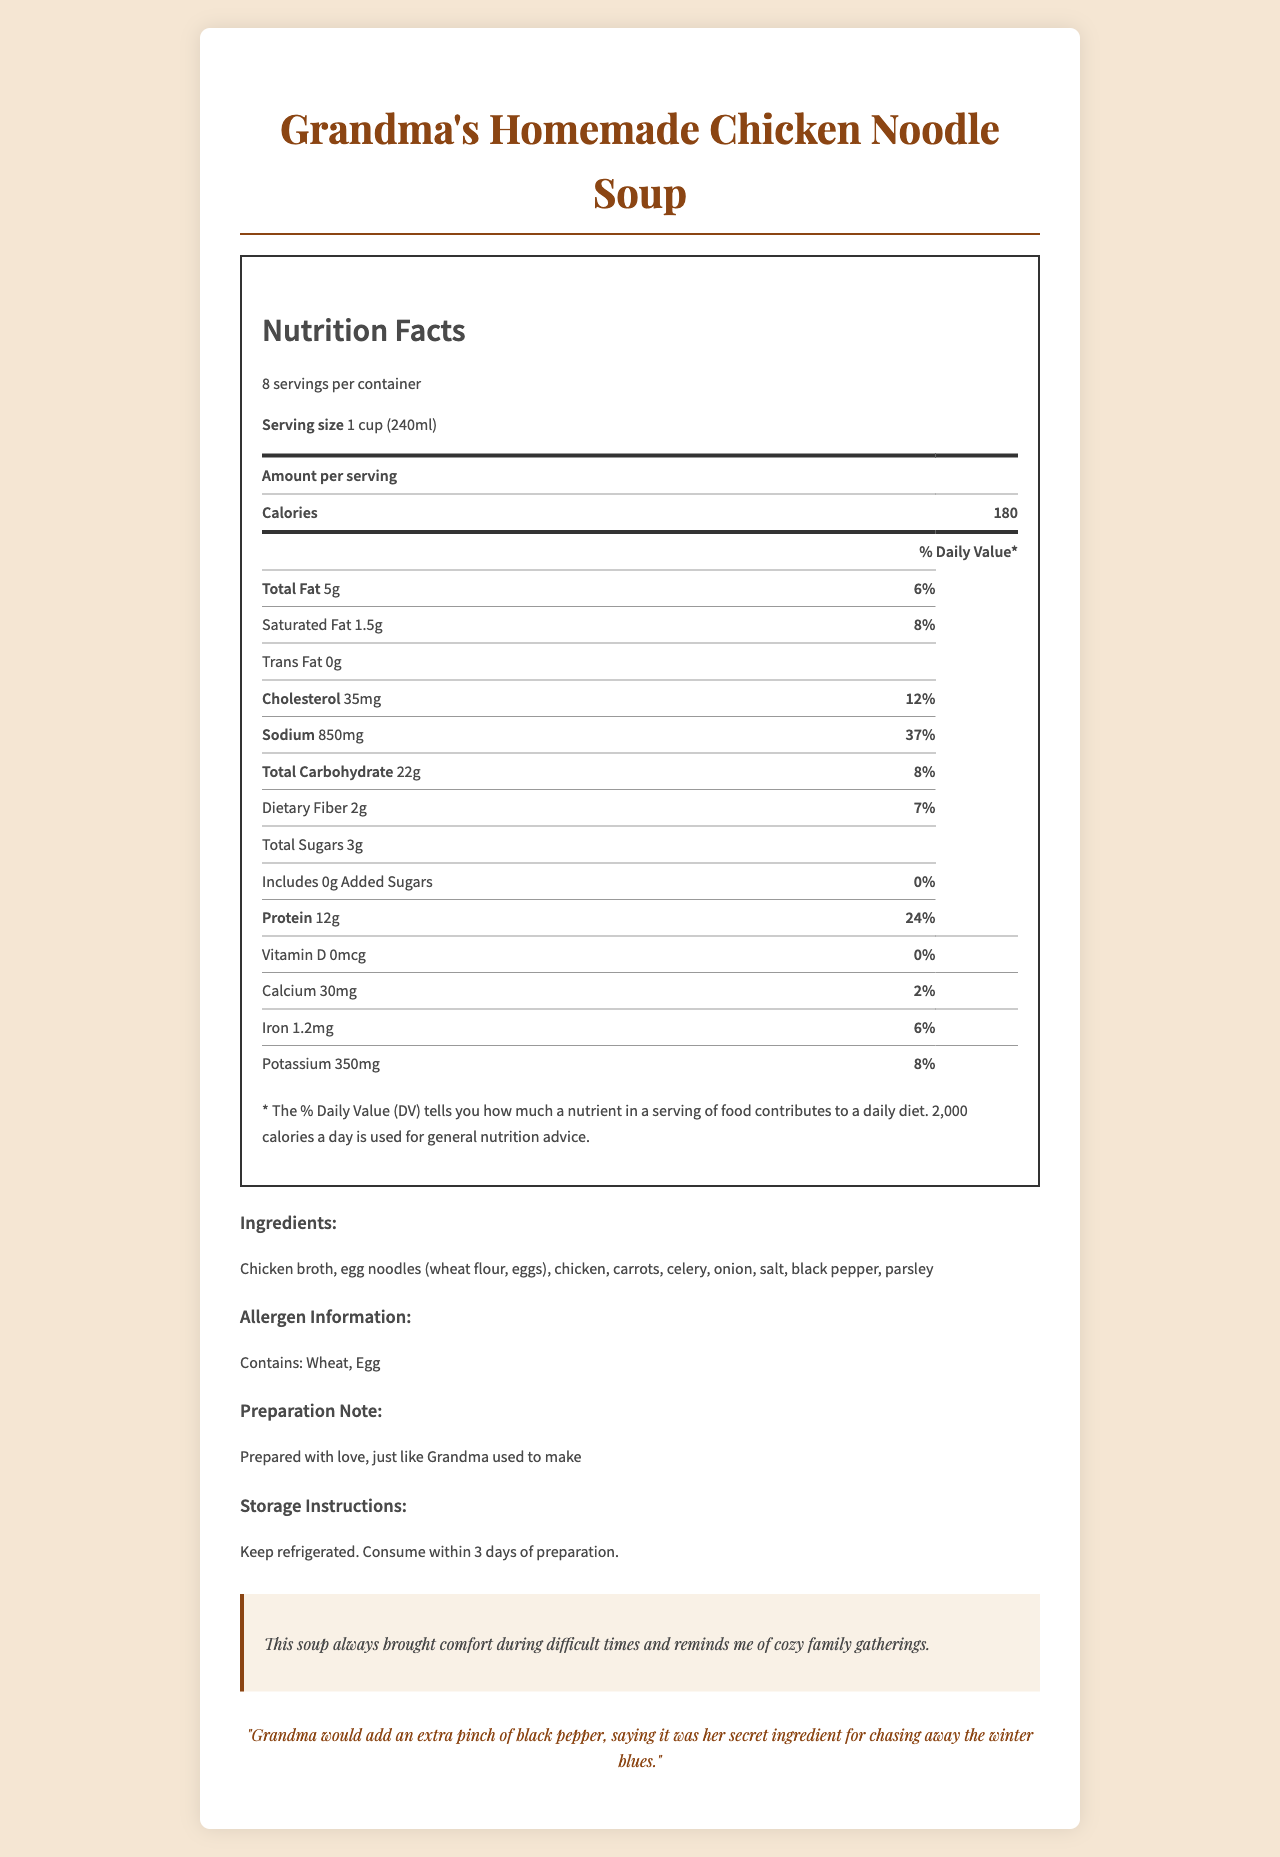what is the serving size for "Grandma's Homemade Chicken Noodle Soup"? The document specifies that the serving size is 1 cup (240ml).
Answer: 1 cup (240ml) how many servings are there per container? The document states that there are 8 servings per container.
Answer: 8 servings how many calories are there per serving of the soup? The document lists the calories per serving as 180.
Answer: 180 calories how much sodium does one serving contain? The document specifies that one serving contains 850 mg of sodium.
Answer: 850 mg which vitamin has a daily value of 0% in the soup? The document indicates that the daily value of Vitamin D is 0%.
Answer: Vitamin D what is the protein content in one serving of the soup? According to the document, one serving of the soup contains 12 g of protein.
Answer: 12 g how should the soup be stored? The document states that the soup should be kept refrigerated and consumed within 3 days of preparation.
Answer: Keep refrigerated. Consume within 3 days of preparation. what are the allergens listed in the document? The document specifies under the allergen information section that the soup contains wheat and egg.
Answer: Wheat, Egg which of the following is a correct daily value percentage? A. Total Fat: 10% B. Saturated Fat: 15% C. Cholesterol: 12% D. Sodium: 25% The document lists the daily value for Cholesterol as 12%.
Answer: C. Cholesterol: 12% which ingredient is not listed in "Grandma's Homemade Chicken Noodle Soup"? A. Chicken B. Egg noodles C. Potatoes D. Carrots The ingredients listed in the document include chicken, egg noodles, carrots, but not potatoes.
Answer: C. Potatoes does the soup contain any trans fat? The document specifies that the trans fat content is 0 grams, indicating none is present.
Answer: No summarize the document in one sentence. The document primarily provides comprehensive nutritional information, ingredients, and a personal emotional significance of the homemade chicken noodle soup.
Answer: The document is a detailed nutrition facts label for "Grandma's Homemade Chicken Noodle Soup," including serving size, nutritional content, ingredients, allergen information, storage instructions, and emotional significance tied to family memories. what is the exact amount of carbohydrates in one serving? The document specifies that one serving contains 22 g of total carbohydrates.
Answer: 22 g how much added sugar does the soup contain? The document states that there is no added sugar in the soup.
Answer: 0 g can you determine the exact age of the grandma who made the soup based on the document? The document does not provide any details about the exact age of the grandma.
Answer: Not enough information 